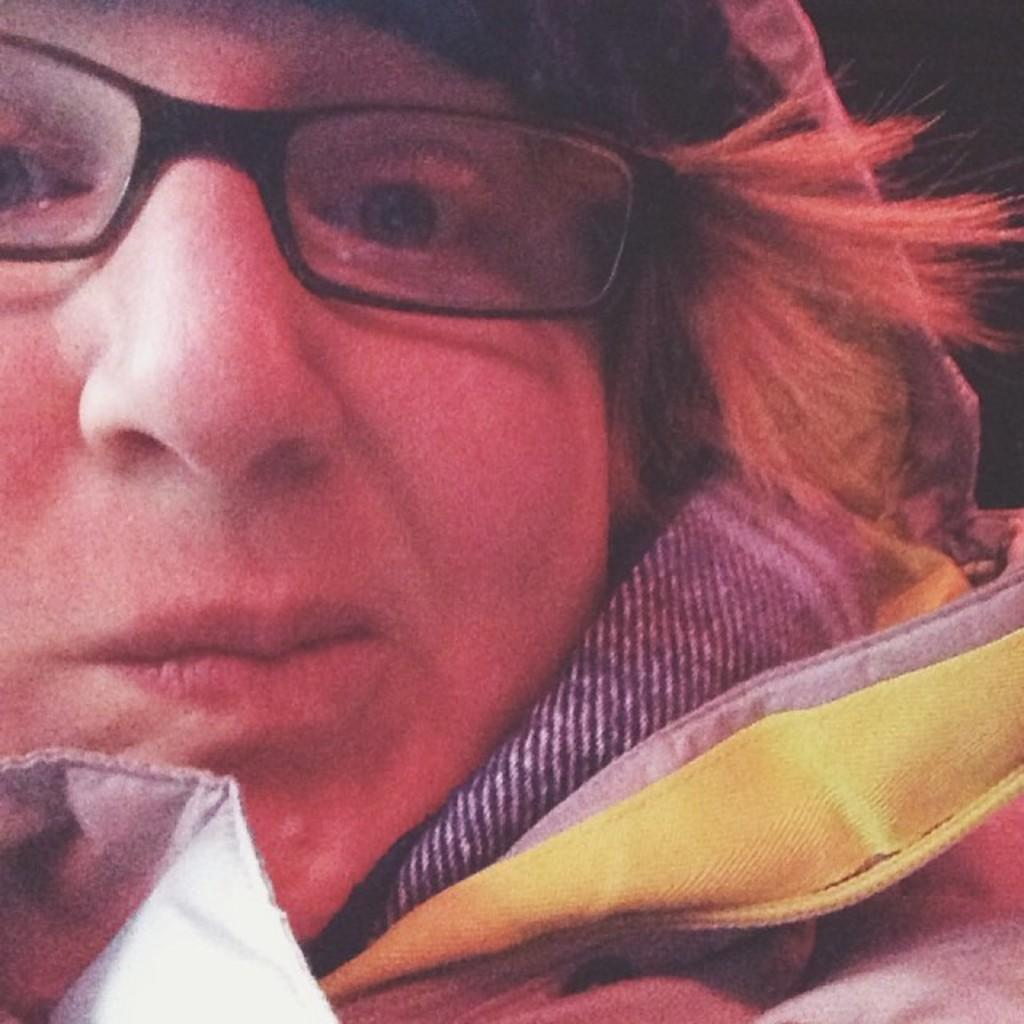What is present in the image? There is a person in the image. Can you describe the person's appearance? The person is wearing clothes and spectacles. How many boys are sitting at the desk in the image? There is no desk or boys present in the image; it only features a person wearing clothes and spectacles. What color is the egg that the person is holding in the image? There is no egg present in the image. 